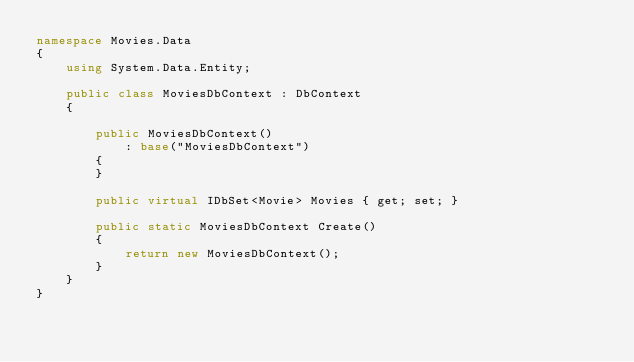Convert code to text. <code><loc_0><loc_0><loc_500><loc_500><_C#_>namespace Movies.Data
{
    using System.Data.Entity;

    public class MoviesDbContext : DbContext
    {

        public MoviesDbContext()
            : base("MoviesDbContext")
        {
        }

        public virtual IDbSet<Movie> Movies { get; set; }

        public static MoviesDbContext Create()
        {
            return new MoviesDbContext();
        }
    }
}</code> 